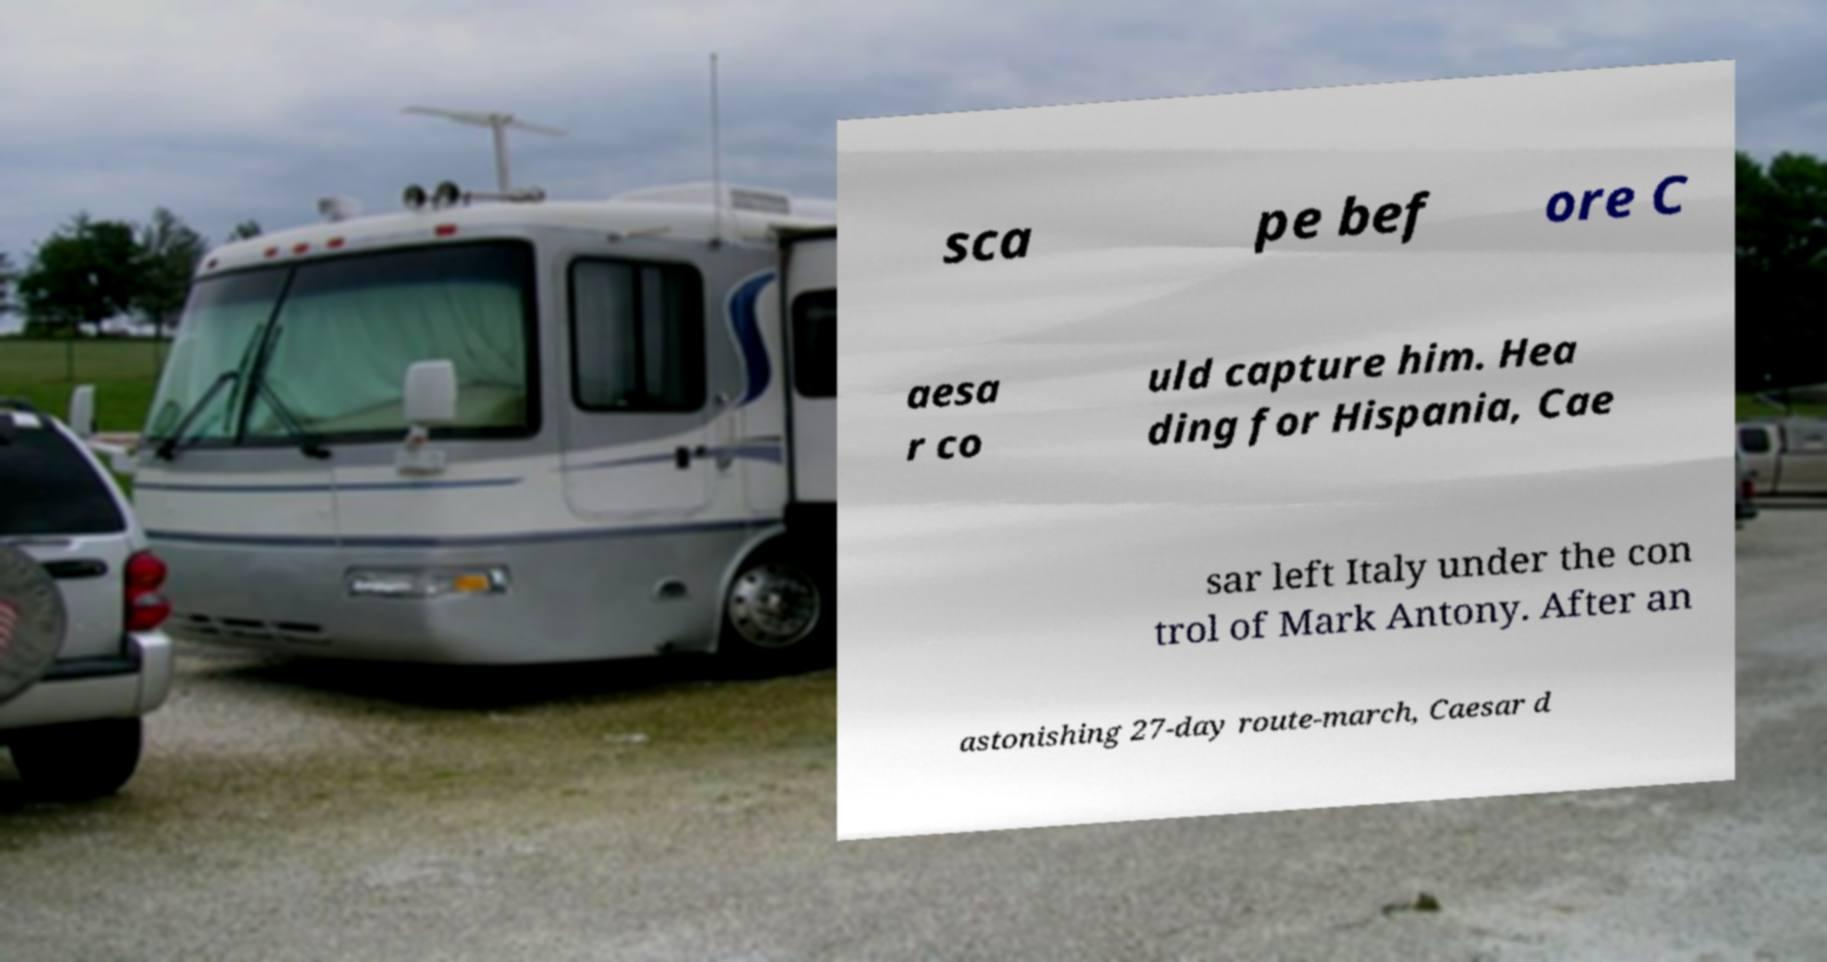What messages or text are displayed in this image? I need them in a readable, typed format. sca pe bef ore C aesa r co uld capture him. Hea ding for Hispania, Cae sar left Italy under the con trol of Mark Antony. After an astonishing 27-day route-march, Caesar d 